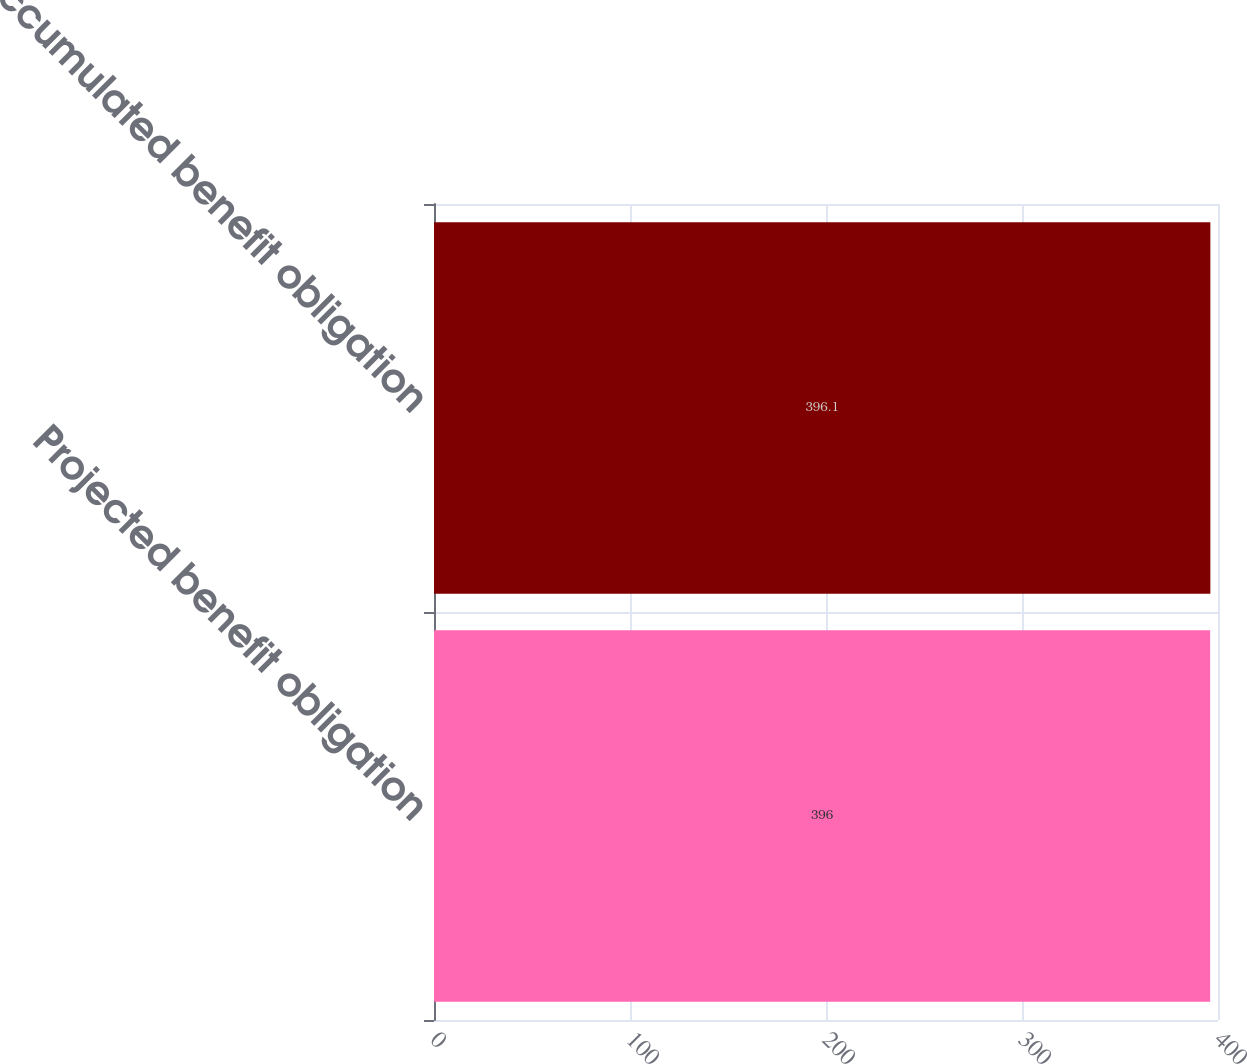Convert chart. <chart><loc_0><loc_0><loc_500><loc_500><bar_chart><fcel>Projected benefit obligation<fcel>Accumulated benefit obligation<nl><fcel>396<fcel>396.1<nl></chart> 